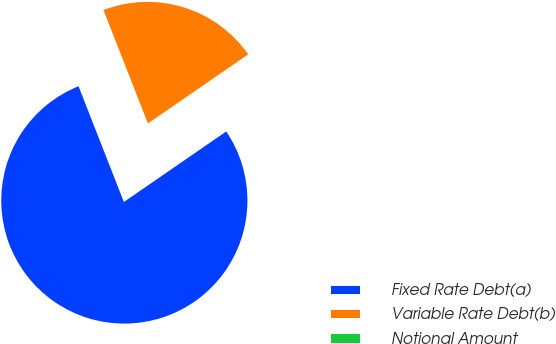Convert chart to OTSL. <chart><loc_0><loc_0><loc_500><loc_500><pie_chart><fcel>Fixed Rate Debt(a)<fcel>Variable Rate Debt(b)<fcel>Notional Amount<nl><fcel>78.66%<fcel>21.34%<fcel>0.0%<nl></chart> 